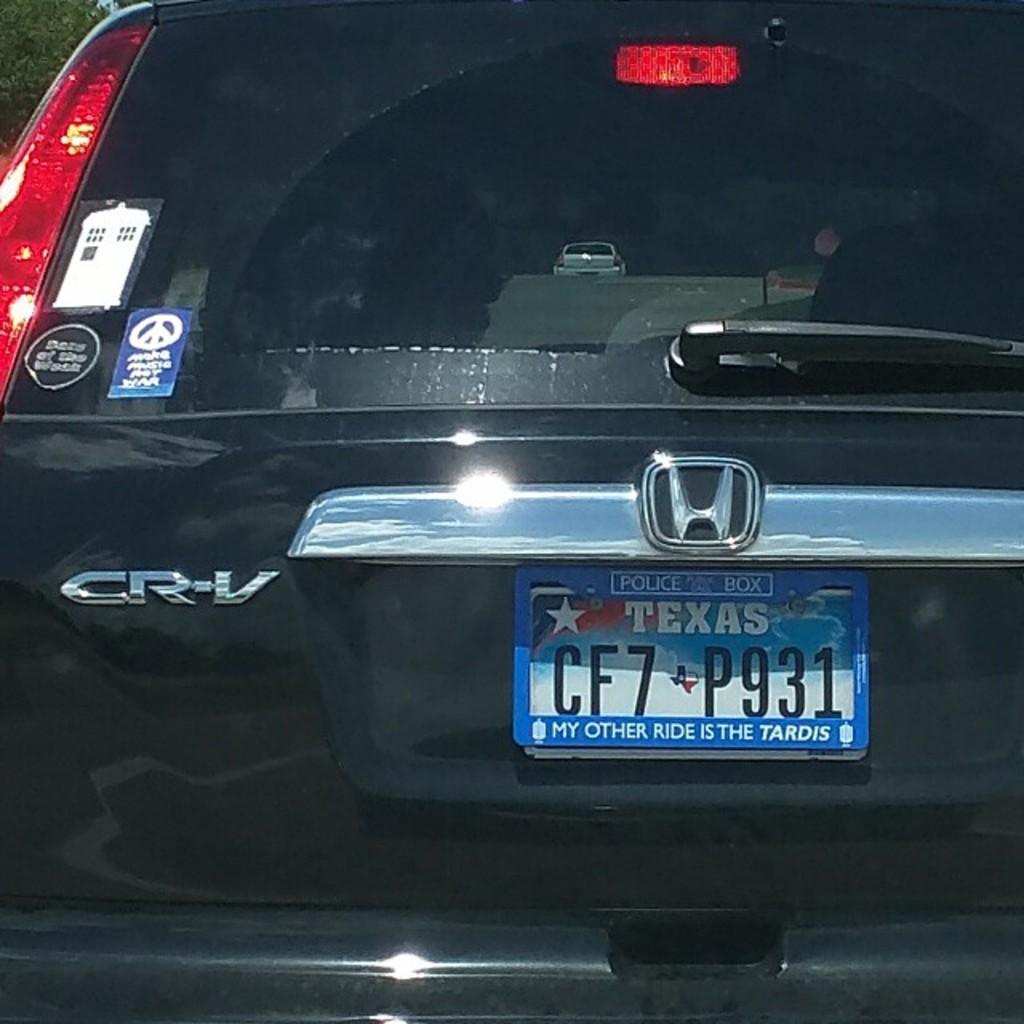<image>
Write a terse but informative summary of the picture. A Honda CRV from Texas has a license plate on it that says My other ride is the Tardis. 